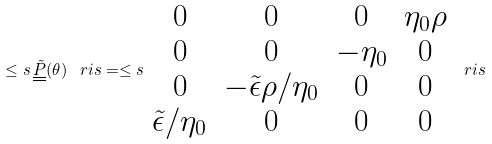<formula> <loc_0><loc_0><loc_500><loc_500>\leq s \, \underline { \underline { \tilde { P } } } ( \theta ) \, \ r i s = \leq s \begin{array} { c c c c } 0 & 0 & 0 & \eta _ { 0 } \rho \\ 0 & 0 & - \eta _ { 0 } & 0 \\ 0 & - \tilde { \epsilon } \rho / \eta _ { 0 } & 0 & 0 \\ \tilde { \epsilon } / \eta _ { 0 } & 0 & 0 & 0 \end{array} \ r i s</formula> 